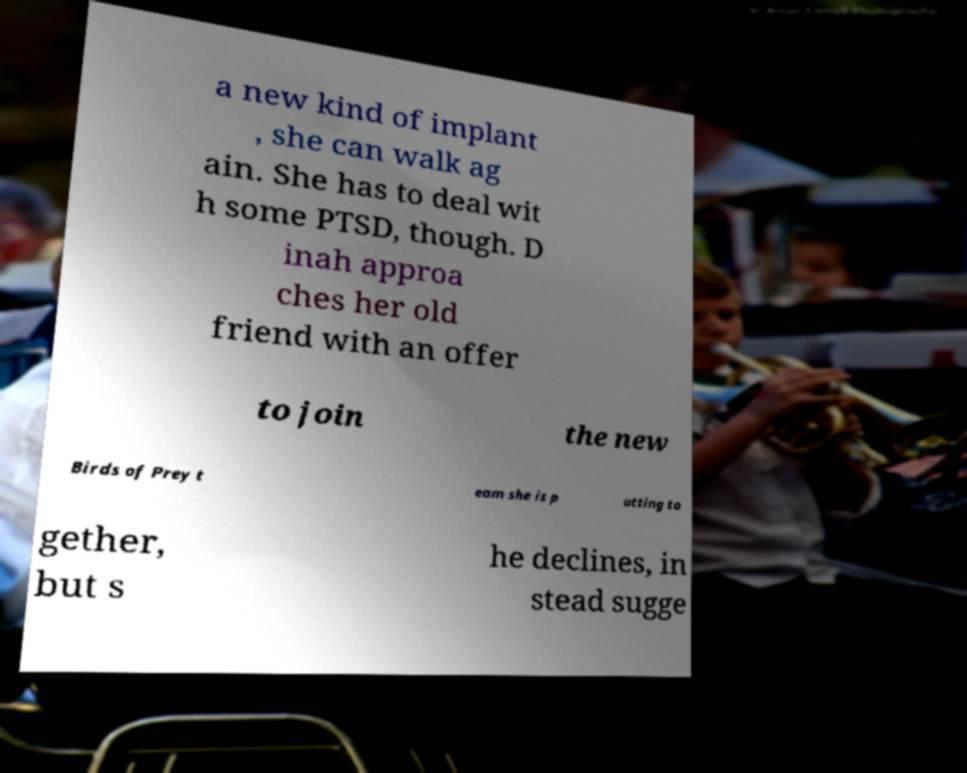Can you read and provide the text displayed in the image?This photo seems to have some interesting text. Can you extract and type it out for me? a new kind of implant , she can walk ag ain. She has to deal wit h some PTSD, though. D inah approa ches her old friend with an offer to join the new Birds of Prey t eam she is p utting to gether, but s he declines, in stead sugge 